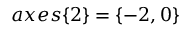Convert formula to latex. <formula><loc_0><loc_0><loc_500><loc_500>a x e s \{ 2 \} = \{ - 2 , 0 \}</formula> 